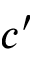<formula> <loc_0><loc_0><loc_500><loc_500>c ^ { \prime }</formula> 